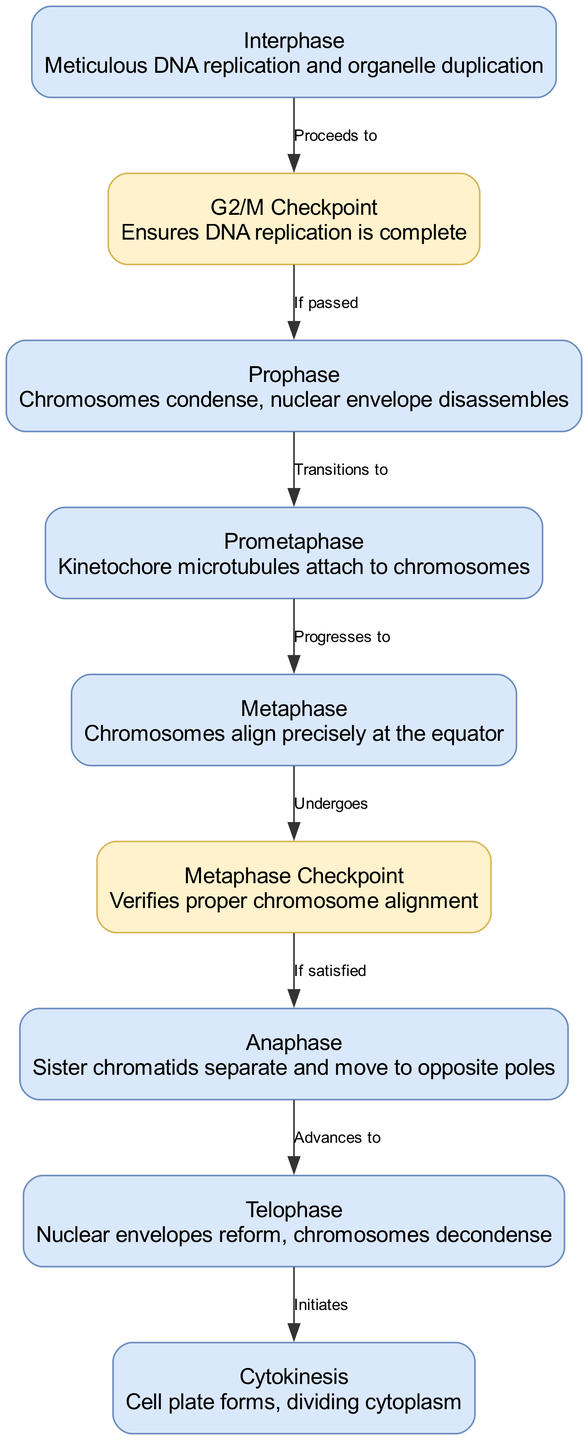What is the first phase of mitosis? The diagram indicates that the first phase of mitosis is labeled as "Interphase" which includes meticulous DNA replication and organelle duplication. Thus, we look at the node that refers to the initial stage of the mitotic process.
Answer: Interphase How many total phases of mitosis are shown in the diagram? The diagram lists seven distinct phases of mitosis: Interphase, Prophase, Prometaphase, Metaphase, Anaphase, Telophase, and Cytokinesis. By counting these nodes, we arrive at the total.
Answer: Seven What happens at the G2/M checkpoint? The diagram describes that the G2/M Checkpoint ensures that DNA replication is complete before proceeding to the next phase. This is detailed in the node associated with the checkpoint, which provides crucial verification for the cell cycle.
Answer: Ensures DNA replication is complete What is the connection between Metaphase and the Metaphase Checkpoint? The diagram illustrates an edge labeled "Undergoes" connecting Metaphase to the Metaphase Checkpoint, indicating that the process of mitosis transitions to the checkpoint phase to verify proper chromosome alignment before continuing.
Answer: Undergoes Which phase comes after Anaphase? According to the directed edges in the diagram, after Anaphase, the next phase that is listed is Telophase. This can be determined by following the directed flow from the relevant node for Anaphase to its subsequent phase.
Answer: Telophase Why is the Metaphase Checkpoint important? The diagram emphasizes that the Metaphase Checkpoint verifies proper chromosome alignment, which is essential for ensuring that the chromosomes are correctly positioned before they are separated. This prevents errors in chromosome distribution, making this checkpoint critical for the accuracy of cell division.
Answer: Verifies proper chromosome alignment What phase involves the formation of the cell plate? The diagram explicitly states that Cytokinesis involves the formation of the cell plate, which is highlighted in the corresponding node dedicated to this final stage of mitosis, marking the physical process of splitting the plant cell.
Answer: Cell plate forms What label indicates the transition to Prophase? Referring to the edges in the diagram, the label that signifies the transition to Prophase is "If passed" from the G2/M Checkpoint, indicating that Prophase follows only if the checkpoint criteria are satisfied.
Answer: If passed 